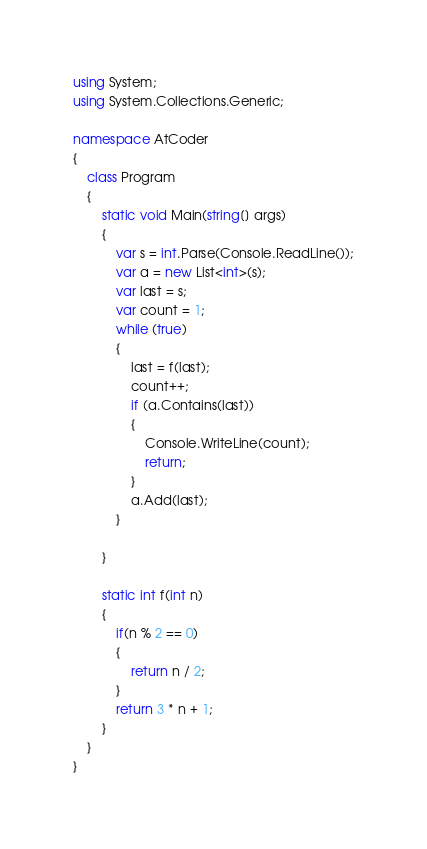Convert code to text. <code><loc_0><loc_0><loc_500><loc_500><_C#_>using System;
using System.Collections.Generic;

namespace AtCoder
{
    class Program
    {
        static void Main(string[] args)
        {
            var s = int.Parse(Console.ReadLine());
            var a = new List<int>(s);
            var last = s;
            var count = 1;
            while (true)
            {
                last = f(last);
                count++;
                if (a.Contains(last))
                {
                    Console.WriteLine(count);
                    return;
                }
                a.Add(last);
            }

        }

        static int f(int n)
        {
            if(n % 2 == 0)
            {
                return n / 2;
            }
            return 3 * n + 1;
        }
    }
}
</code> 